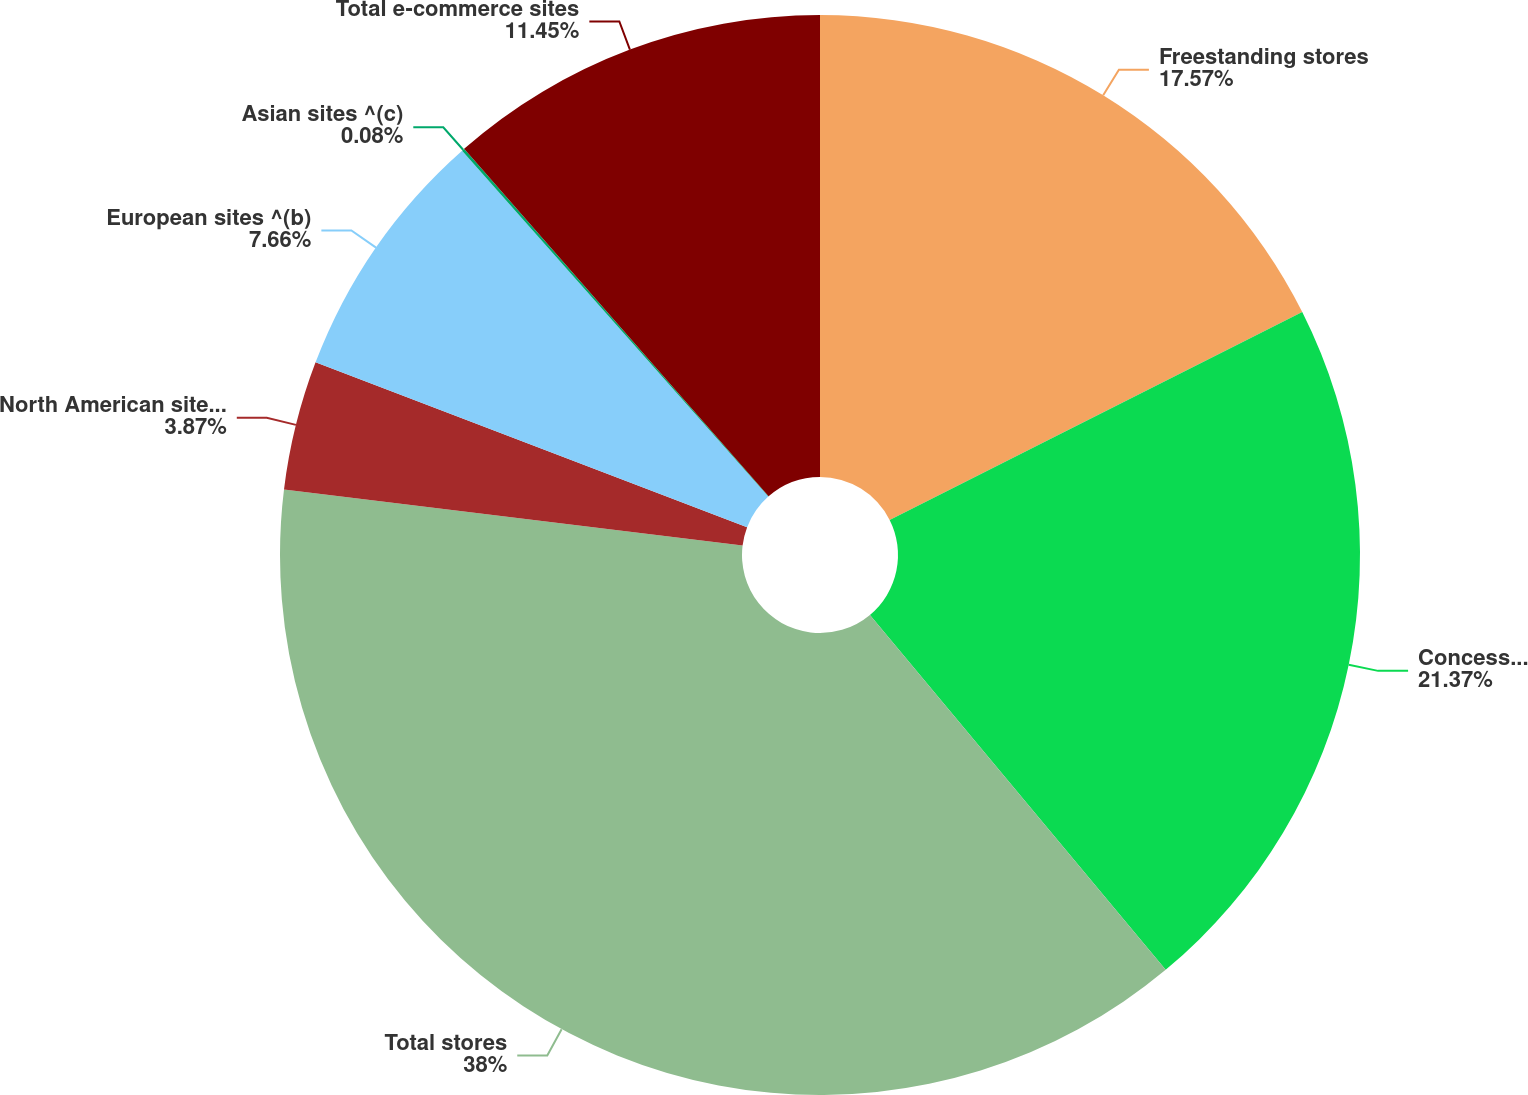Convert chart to OTSL. <chart><loc_0><loc_0><loc_500><loc_500><pie_chart><fcel>Freestanding stores<fcel>Concession shops<fcel>Total stores<fcel>North American sites ^(a)<fcel>European sites ^(b)<fcel>Asian sites ^(c)<fcel>Total e-commerce sites<nl><fcel>17.57%<fcel>21.37%<fcel>37.99%<fcel>3.87%<fcel>7.66%<fcel>0.08%<fcel>11.45%<nl></chart> 